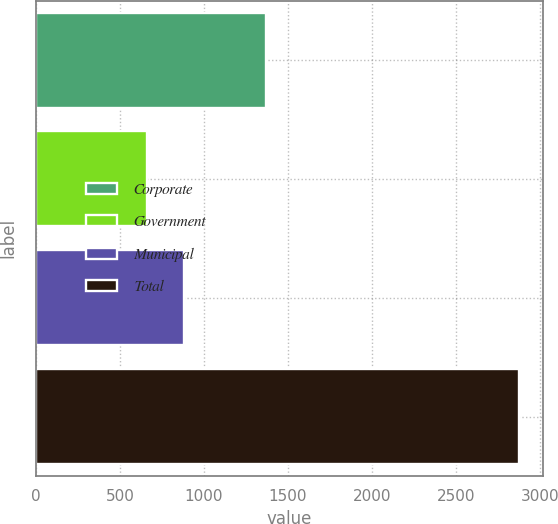<chart> <loc_0><loc_0><loc_500><loc_500><bar_chart><fcel>Corporate<fcel>Government<fcel>Municipal<fcel>Total<nl><fcel>1368<fcel>659<fcel>880.8<fcel>2877<nl></chart> 